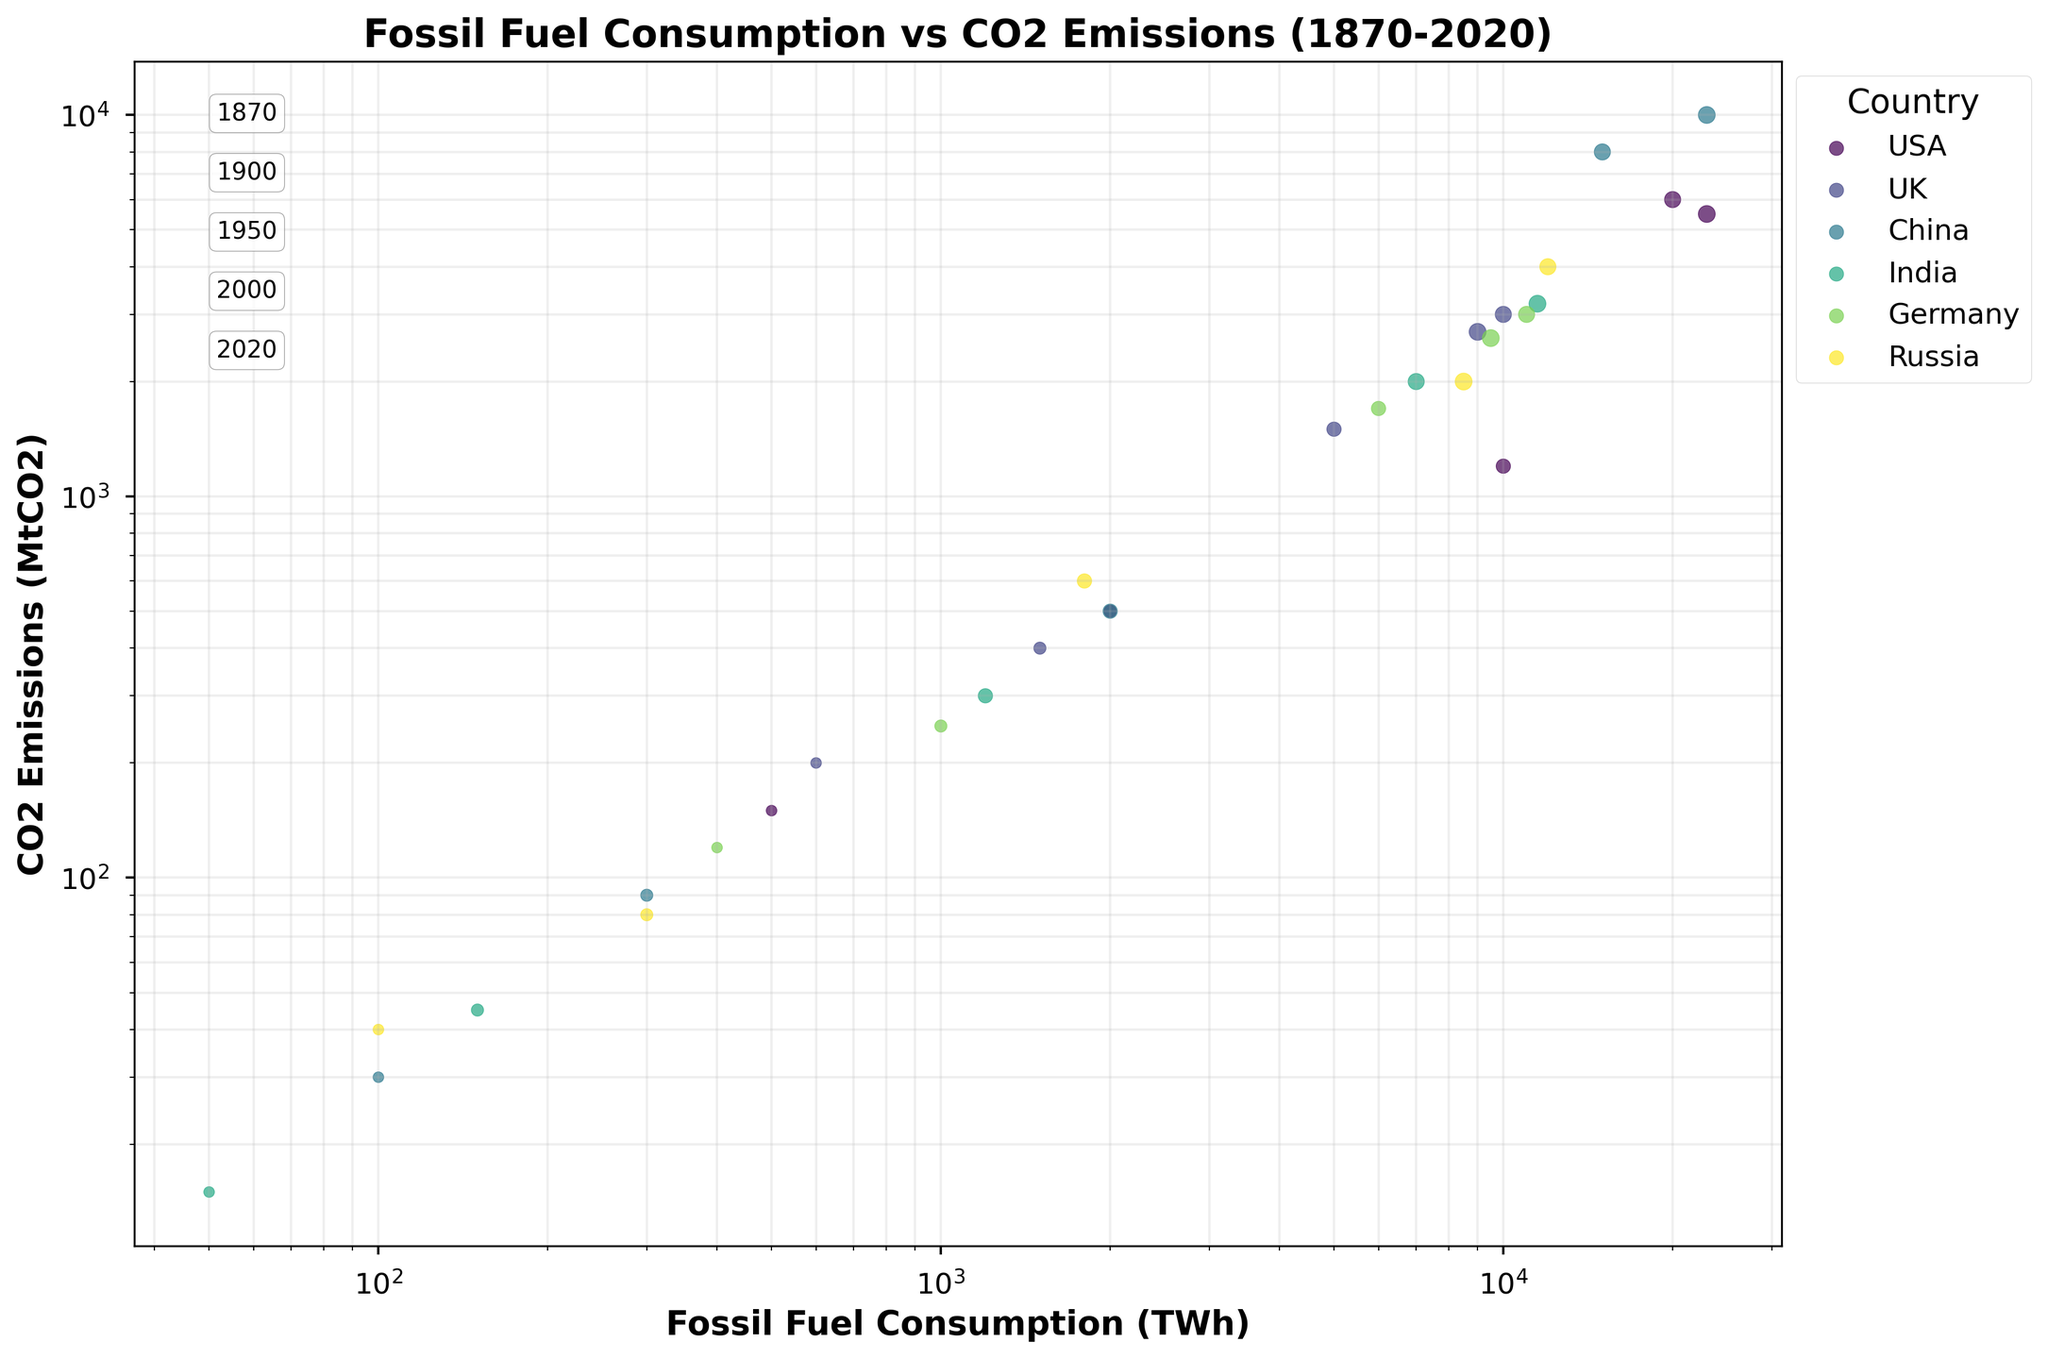What is the title of the figure? The title is written at the top of the figure, which is "Fossil Fuel Consumption vs CO2 Emissions (1870-2020)"
Answer: Fossil Fuel Consumption vs CO2 Emissions (1870-2020) Which country has the highest CO2 emissions in 2020? In the figure, locate the 2020 annotations and look for the highest y-value among the points labeled for 2020. China has the highest CO2 emissions in 2020.
Answer: China How do the CO2 emissions of the USA in 1950 compare with those in 2000? Locate the points for the USA for the years 1950 and 2000. The y-values represent the CO2 emissions. The emissions in 2000 (6000 MtCO2) are higher than in 1950 (1200 MtCO2).
Answer: Higher in 2000 What are the axis labels for the x-axis and y-axis? The x-axis and y-axis labels are written in bold text along the axes. The x-axis label is "Fossil Fuel Consumption (TWh)" and the y-axis label is "CO2 Emissions (MtCO2)"
Answer: Fossil Fuel Consumption (TWh) and CO2 Emissions (MtCO2) Which country shows the most rapid increase in fossil fuel consumption between 1950 and 2000? Compare the slope of the lines connecting the 1950 and 2000 points for each country. China exhibits the steepest increase in fossil fuel consumption.
Answer: China Are there any countries for which CO2 emissions decreased between 2000 and 2020? Observe the y-values for the points labeled 2000 and 2020 for each country. The USA and Germany show a decrease in CO2 emissions between these years.
Answer: USA and Germany Which country had the least fossil fuel consumption in 1870? Look for the lowest x-value among the points labeled 1870. India had the least fossil fuel consumption in 1870.
Answer: India How do the CO2 emissions of China in 2020 compare with those of the USA in 2020? Compare the y-values of the points representing China's and the USA's CO2 emissions in 2020. China has higher CO2 emissions (10000 MtCO2) compared to the USA (5500 MtCO2).
Answer: China has higher emissions What is the pattern of fossil fuel consumption of the UK from 1870 to 2020? Trace the x-values of the UK's points from 1870 to 2020. The UK's fossil fuel consumption increases until 2000 and shows a slight decrease by 2020.
Answer: Increase until 2000, then slight decrease What is the general trend observed between fossil fuel consumption and CO2 emissions for the countries over the 150 years? Log-log scale plots show a clearer pattern; observe the overall distribution of points. Generally, higher fossil fuel consumption correlates with higher CO2 emissions.
Answer: Positive correlation 